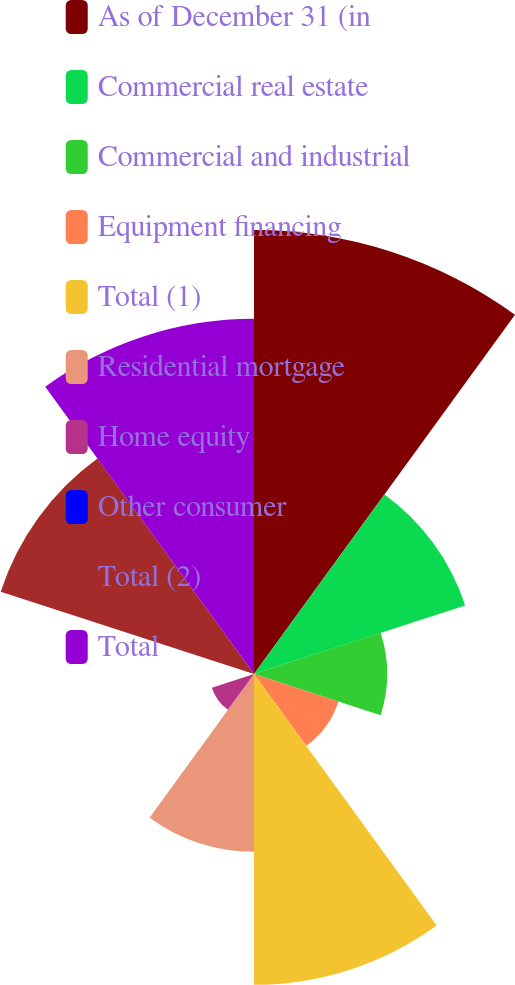Convert chart. <chart><loc_0><loc_0><loc_500><loc_500><pie_chart><fcel>As of December 31 (in<fcel>Commercial real estate<fcel>Commercial and industrial<fcel>Equipment financing<fcel>Total (1)<fcel>Residential mortgage<fcel>Home equity<fcel>Other consumer<fcel>Total (2)<fcel>Total<nl><fcel>21.74%<fcel>10.87%<fcel>6.52%<fcel>4.35%<fcel>15.22%<fcel>8.7%<fcel>2.17%<fcel>0.0%<fcel>13.04%<fcel>17.39%<nl></chart> 